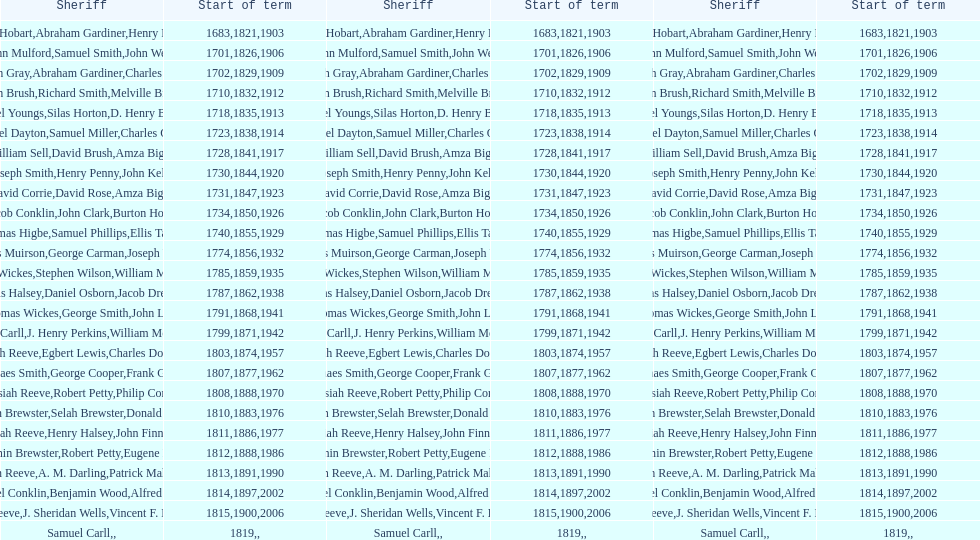Who was the sheriff prior to thomas wickes? James Muirson. 